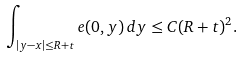Convert formula to latex. <formula><loc_0><loc_0><loc_500><loc_500>\int _ { | y - x | \leq R + t } e ( 0 , y ) \, d y \leq C ( R + t ) ^ { 2 } .</formula> 